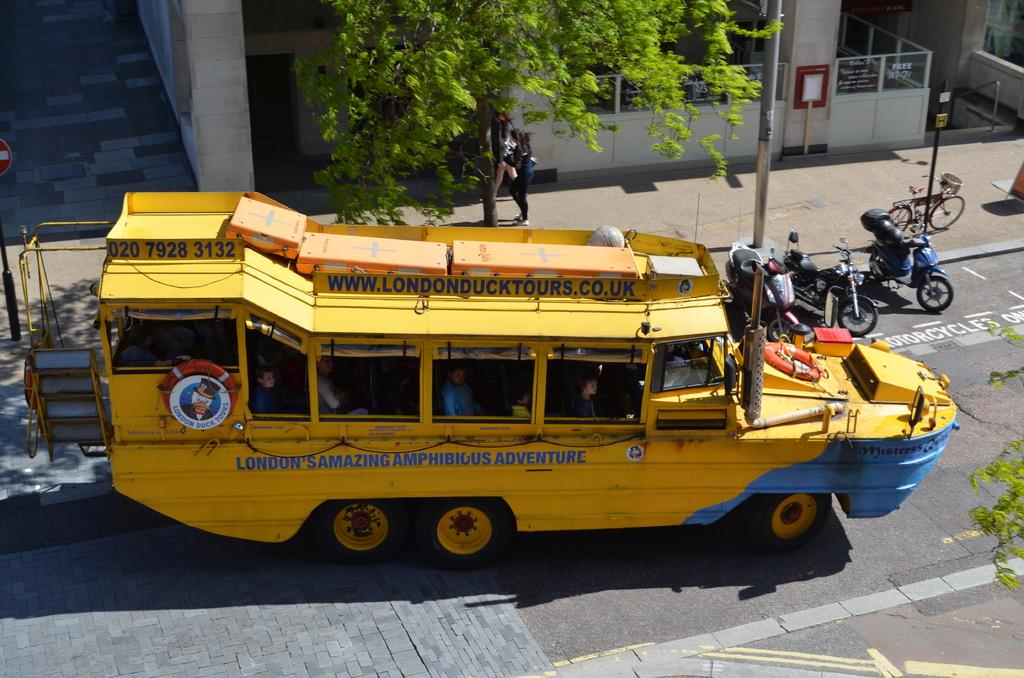What is happening in the foreground of the image? There is a vehicle moving in the foreground of the image. Where is the moving vehicle located? The vehicle is on the road. What can be seen in the background of the image? There are vehicles parked, poles, a building, a tree, and a sign board visible in the background of the image. How many parked vehicles can be seen in the background? There are vehicles parked in the background of the image, but the exact number is not specified. Where is the faucet located in the image? There is no faucet present in the image. What type of art can be seen on the sign board in the image? The image does not provide information about any art on the sign board. 